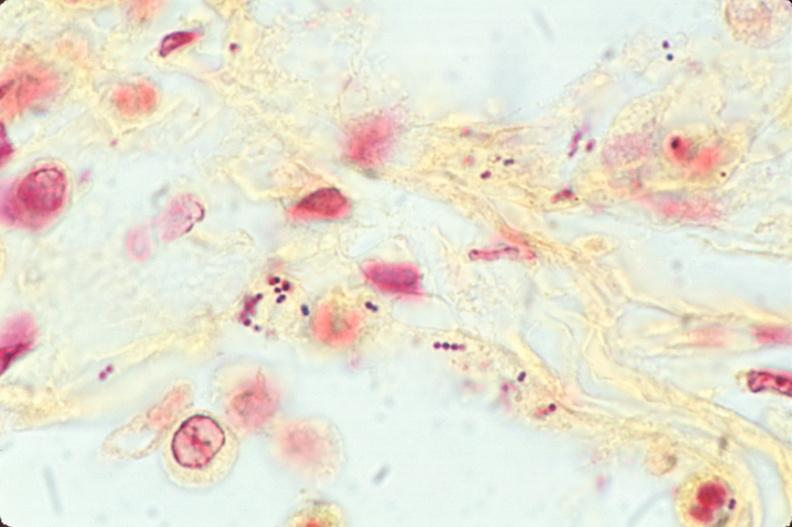s respiratory present?
Answer the question using a single word or phrase. Yes 